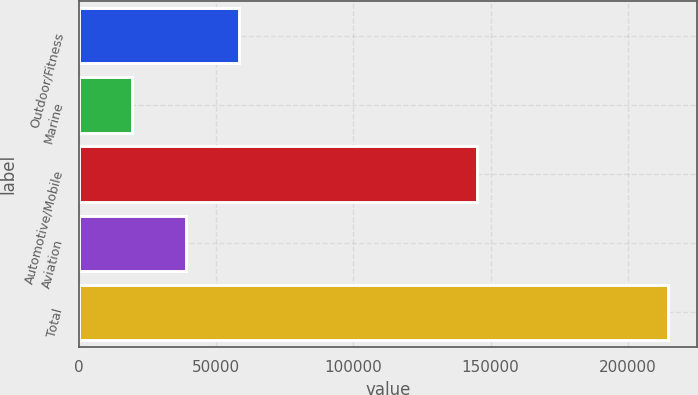Convert chart. <chart><loc_0><loc_0><loc_500><loc_500><bar_chart><fcel>Outdoor/Fitness<fcel>Marine<fcel>Automotive/Mobile<fcel>Aviation<fcel>Total<nl><fcel>58348.2<fcel>19307<fcel>145113<fcel>38827.6<fcel>214513<nl></chart> 